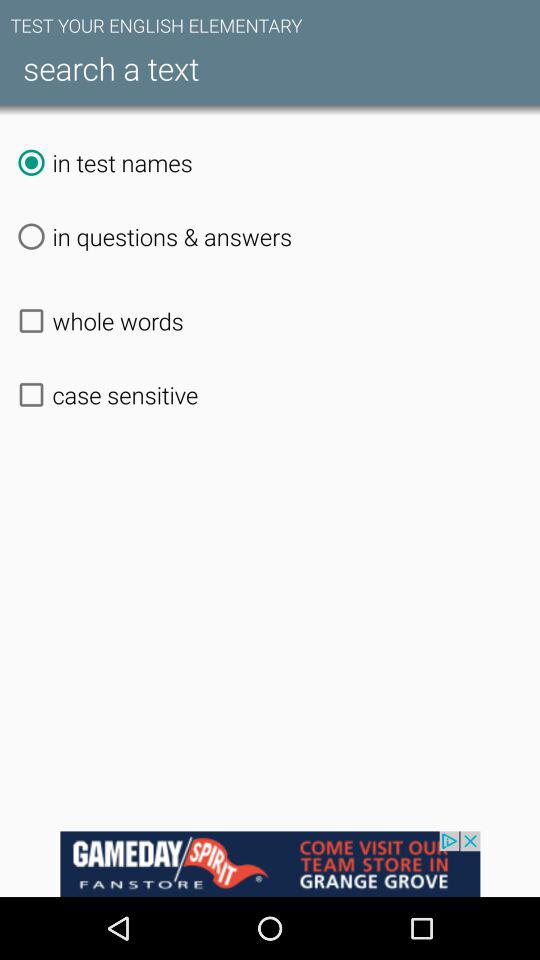What is the status of "case sensitive"? The status of "case sensitive" is "off". 